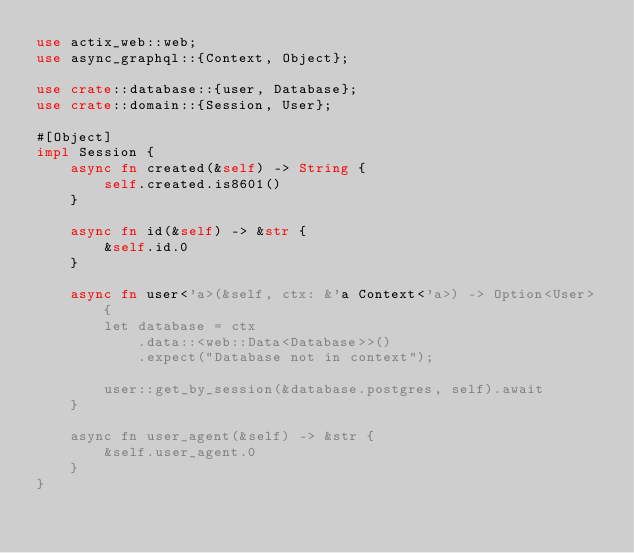Convert code to text. <code><loc_0><loc_0><loc_500><loc_500><_Rust_>use actix_web::web;
use async_graphql::{Context, Object};

use crate::database::{user, Database};
use crate::domain::{Session, User};

#[Object]
impl Session {
    async fn created(&self) -> String {
        self.created.is8601()
    }

    async fn id(&self) -> &str {
        &self.id.0
    }

    async fn user<'a>(&self, ctx: &'a Context<'a>) -> Option<User> {
        let database = ctx
            .data::<web::Data<Database>>()
            .expect("Database not in context");

        user::get_by_session(&database.postgres, self).await
    }

    async fn user_agent(&self) -> &str {
        &self.user_agent.0
    }
}
</code> 